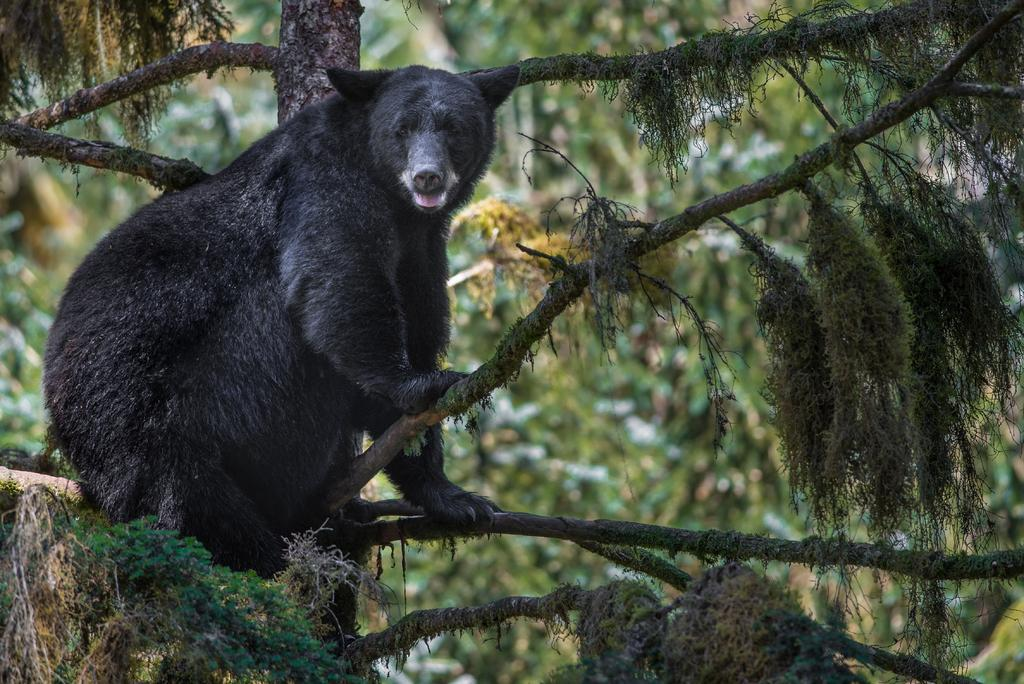What animal is in the picture? There is a bear in the picture. What color is the bear? The bear is black in color. What is the bear doing in the picture? The bear is sitting on a tree. What can be seen in the background of the image? There are trees and leaves visible in the background. What type of paste is the bear using to stick the leaves together in the image? There is no paste or activity involving leaves in the image; the bear is simply sitting on a tree. 